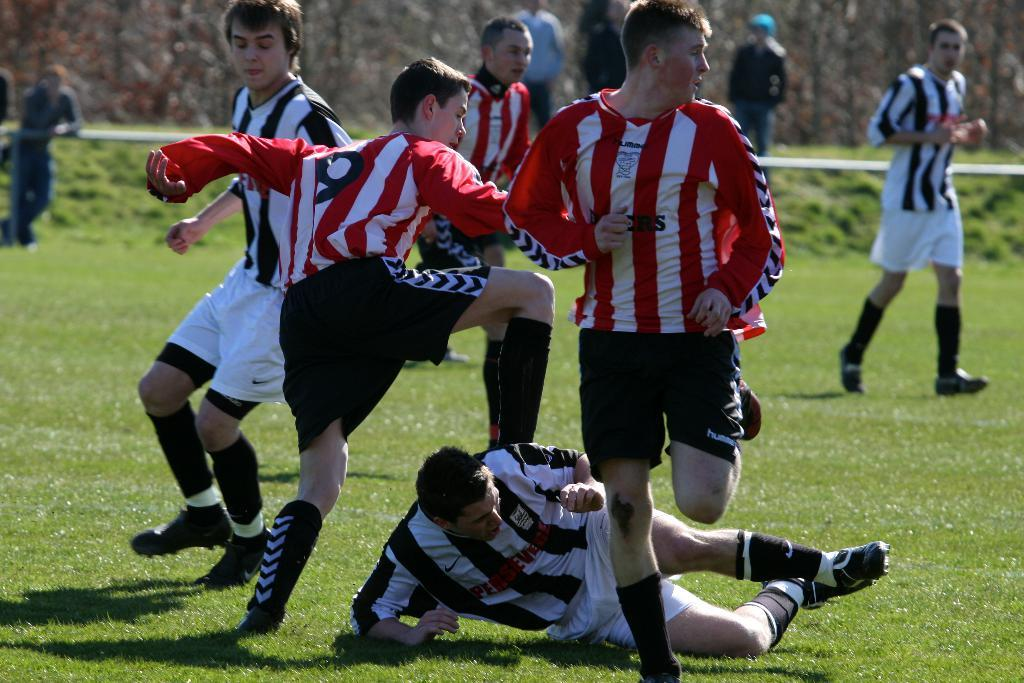What activity is taking place in the image? There are players playing in a ground in the image. Can you describe the position of a person in the image? A man is lying in the image. What can be seen in the background of the image? There are people standing in the background and trees visible in the background. How would you describe the quality of the image? The image is blurred. What type of question is being asked by the mouth on the shelf in the image? There is no mouth or shelf present in the image. 